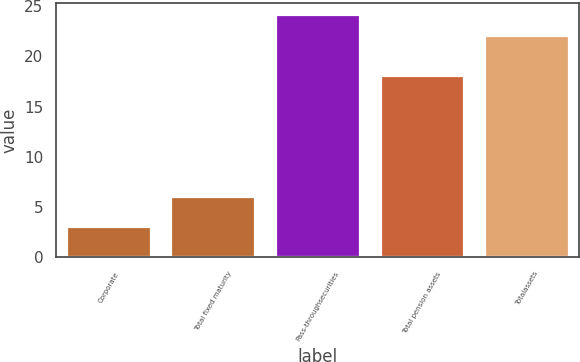Convert chart to OTSL. <chart><loc_0><loc_0><loc_500><loc_500><bar_chart><fcel>Corporate<fcel>Total fixed maturity<fcel>Pass-throughsecurities<fcel>Total pension assets<fcel>Totalassets<nl><fcel>3<fcel>6<fcel>24.1<fcel>18<fcel>22<nl></chart> 